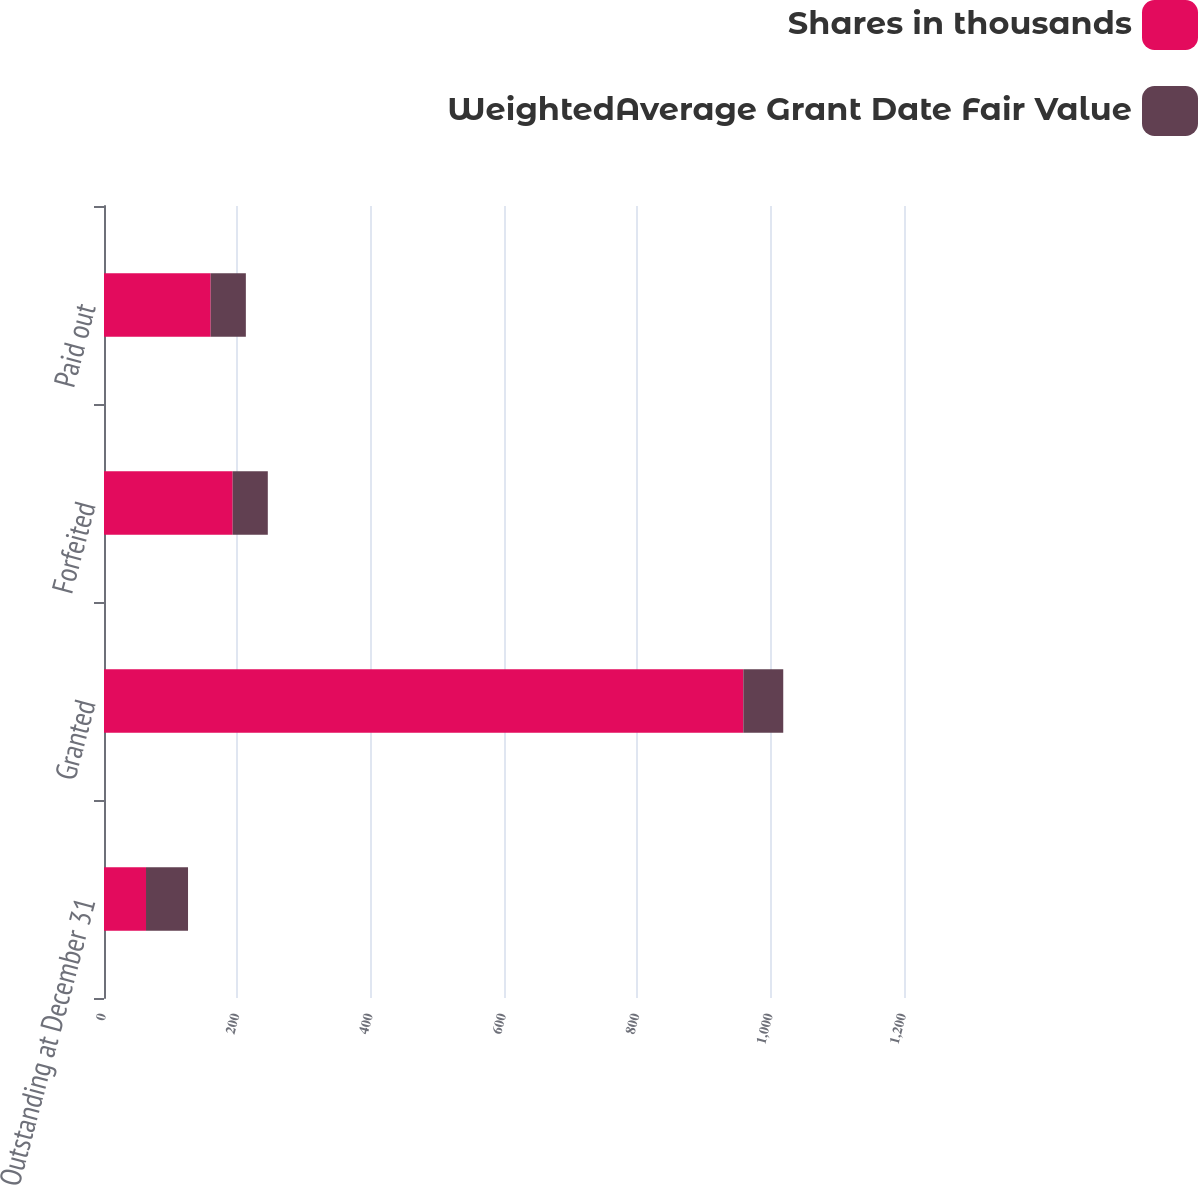Convert chart. <chart><loc_0><loc_0><loc_500><loc_500><stacked_bar_chart><ecel><fcel>Outstanding at December 31<fcel>Granted<fcel>Forfeited<fcel>Paid out<nl><fcel>Shares in thousands<fcel>63.02<fcel>959<fcel>193<fcel>160<nl><fcel>WeightedAverage Grant Date Fair Value<fcel>63.02<fcel>59.87<fcel>52.71<fcel>52.78<nl></chart> 